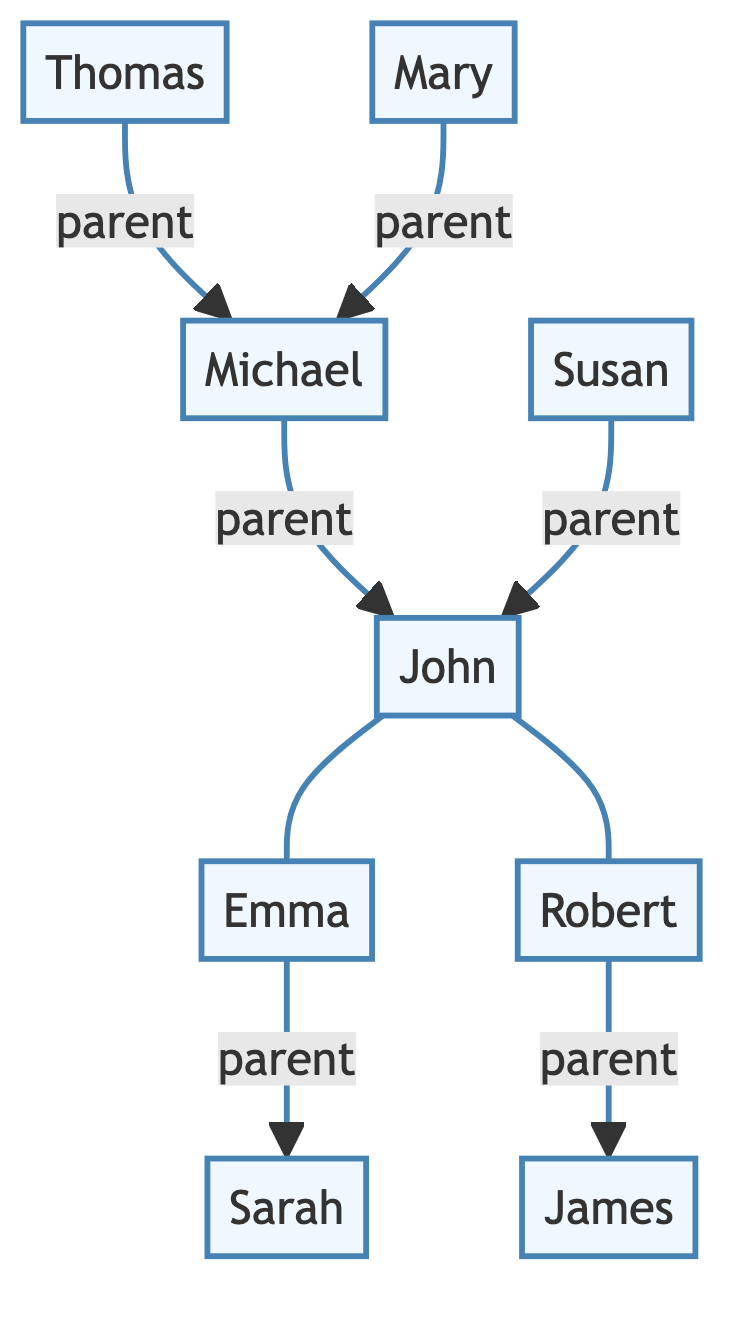What is John's relationship to Emma? In the diagram, John is connected to Emma by a two-way line, which indicates they are married. Thus, John's relationship to Emma is that she is his spouse.
Answer: spouse How many children do John and Emma have? By examining the diagram, John is connected to two children: Sarah and Thomas. Therefore, John and Emma have two children.
Answer: two Who are John's parents? In the diagram, John is connected to two nodes, Michael and Susan, which indicates that they are his parents. Therefore, John's parents are Michael and Susan.
Answer: Michael and Susan What is the lineage connection between Mary and John? To determine the connection, we trace from Mary to her child, who is linked to Michael. Since Michael is one of John's parents, Mary would be John's grandparent. Thus, Mary is John's grandparent.
Answer: grandparent How many total individuals are in this family tree? The diagram displays a total of nine individuals, including John and his relatives. To get the total, we count each distinct individual present in the diagram: John, Michael, Susan, Emma, Robert, Thomas, Mary, Sarah, and James.
Answer: nine Who is John's sibling? By checking John's connections, he has one sibling, Thomas, who is indicated alongside him in the diagram as his brother. Hence, John's sibling is Thomas.
Answer: Thomas What is the connection between Robert and John? In the diagram, Robert is connected to John through their parent-child relationship, with John being Robert's parent. Thus, Robert is John’s child.
Answer: child Which two individuals are married in this diagram? The diagram indicates a marriage between John and Emma, as shown by the two-way line connecting them. Therefore, the two individuals who are married in this diagram are John and Emma.
Answer: John and Emma 